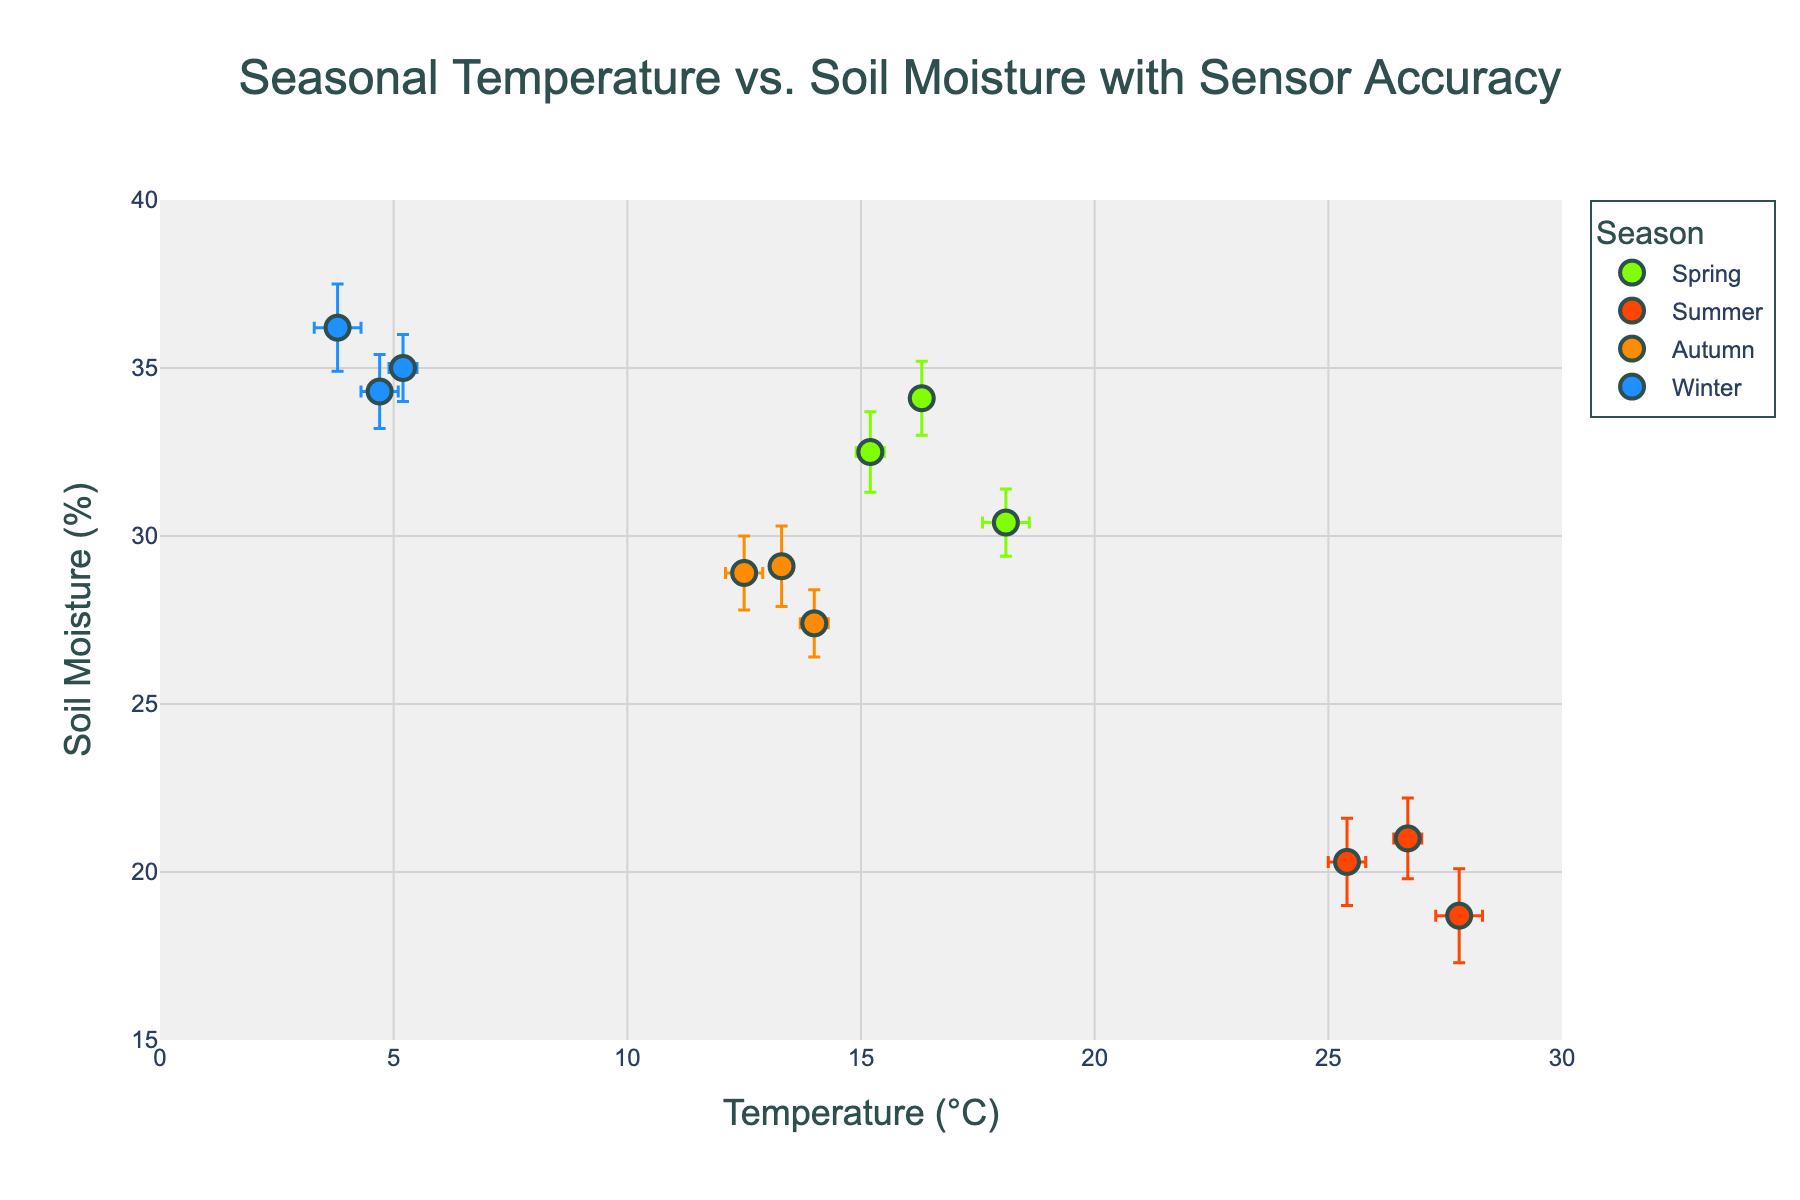What does the title of the figure say? The title is usually displayed prominently at the top of the figure. It provides a brief description of what the plot is about. Here, the title reads "Seasonal Temperature vs. Soil Moisture with Sensor Accuracy".
Answer: Seasonal Temperature vs. Soil Moisture with Sensor Accuracy What information is given on the x-axis and y-axis? The x-axis typically represents one variable, and the y-axis represents another. In this plot, the x-axis title is "Temperature (°C)", and the y-axis title is "Soil Moisture (%)".
Answer: x-axis: Temperature (°C), y-axis: Soil Moisture (%) Which season shows the highest temperatures? By observing the range of temperatures (x-axis) for each season, we can compare which season has the highest values. Summer has temperatures ranging up to around 27.8°C, the highest among the seasons.
Answer: Summer What is the approximate range of soil moisture percentages for Winter? To determine this, look at the y-axis values for the Winter data points. They range approximately from 34.3% to 36.2%.
Answer: 34.3% to 36.2% How many data points are there for each season? By counting the markers for each color corresponding to a different season, we find three data points for each of Spring, Summer, Autumn, and Winter.
Answer: 3 for each season How does soil moisture in Autumn compare to soil moisture in Winter? To compare, observe the data points for Autumn and Winter along the y-axis. Autumn has soil moisture values ranging from 27.4% to 29.1%, whereas Winter ranges from 34.3% to 36.2%. Thus, Winter has higher soil moisture levels than Autumn.
Answer: Winter has higher soil moisture levels than Autumn What is the average temperature for Spring? The temperatures for Spring are 15.2°C, 18.1°C, and 16.3°C. Summing these up we get 49.6°C, and dividing by 3 gives us the average: 49.6/3 = 16.53°C.
Answer: 16.53°C Which season has the widest range of soil moisture values? By checking the spread of soil moisture values, Summer shows a range from 18.7% to 21.0%, which is a range of 2.3%. Spring's range is 30.4% to 34.1% (3.7%), Autumn's range is 27.4% to 29.1% (1.7%), and Winter's range is 34.3% to 36.2% (1.9%). Thus, Spring has the widest range.
Answer: Spring What does the color of the markers represent? The color of the markers indicates the season. This can be understood from the color legend associated with the marker colors in the plot.
Answer: Season 